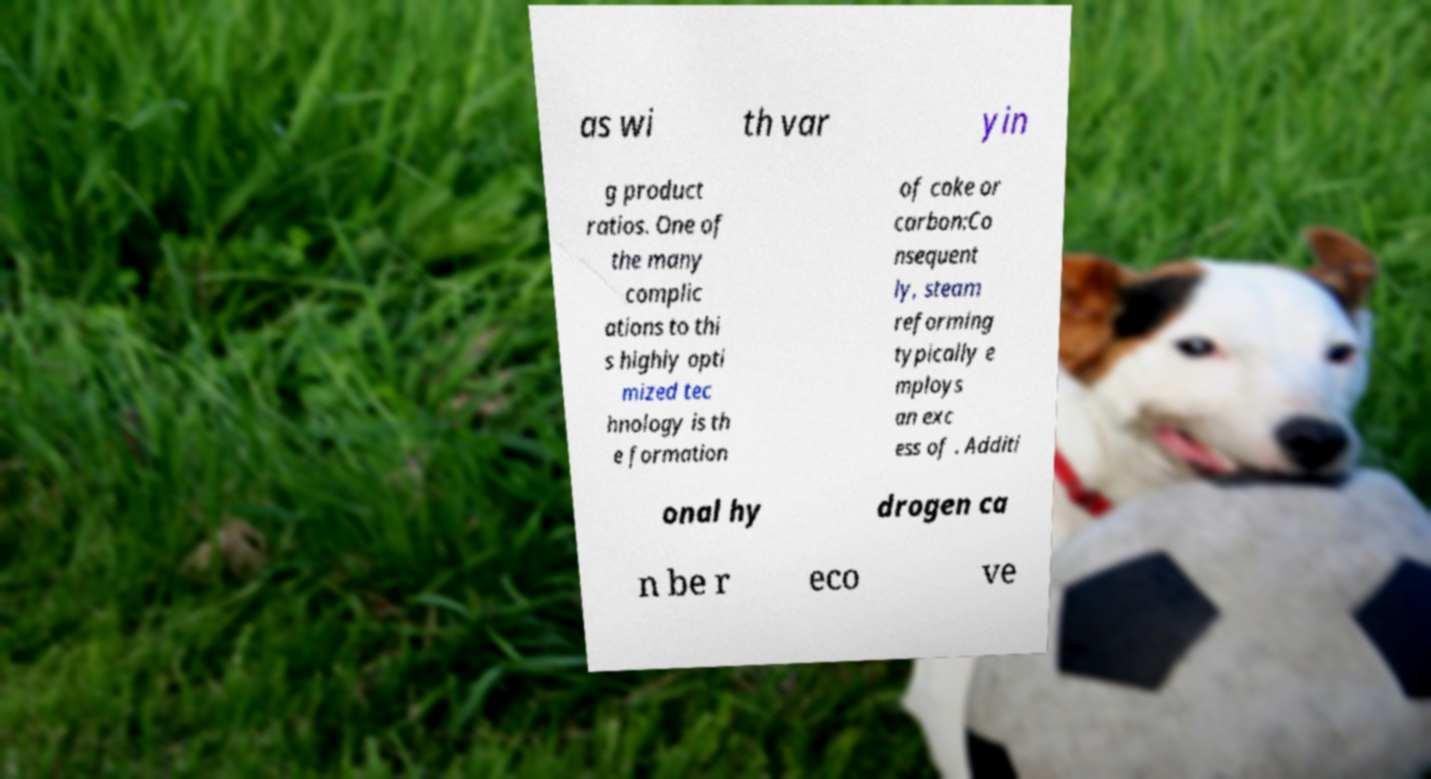Could you assist in decoding the text presented in this image and type it out clearly? as wi th var yin g product ratios. One of the many complic ations to thi s highly opti mized tec hnology is th e formation of coke or carbon:Co nsequent ly, steam reforming typically e mploys an exc ess of . Additi onal hy drogen ca n be r eco ve 